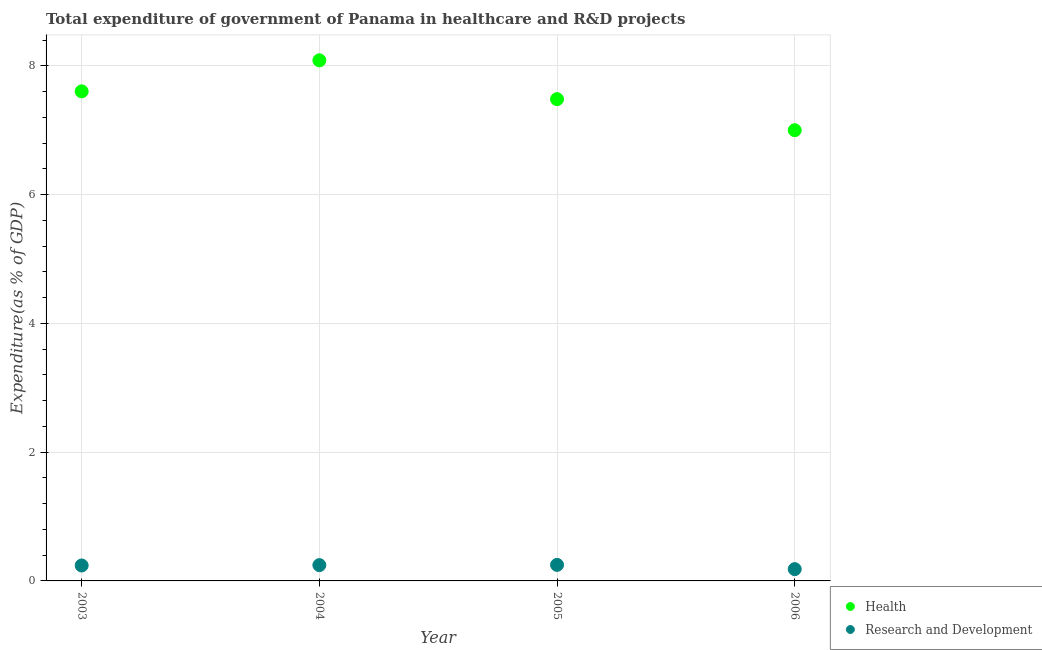How many different coloured dotlines are there?
Provide a short and direct response. 2. Is the number of dotlines equal to the number of legend labels?
Make the answer very short. Yes. What is the expenditure in r&d in 2006?
Provide a succinct answer. 0.18. Across all years, what is the maximum expenditure in r&d?
Keep it short and to the point. 0.25. Across all years, what is the minimum expenditure in healthcare?
Make the answer very short. 7. In which year was the expenditure in healthcare minimum?
Ensure brevity in your answer.  2006. What is the total expenditure in healthcare in the graph?
Keep it short and to the point. 30.18. What is the difference between the expenditure in r&d in 2005 and that in 2006?
Offer a terse response. 0.07. What is the difference between the expenditure in healthcare in 2004 and the expenditure in r&d in 2005?
Make the answer very short. 7.84. What is the average expenditure in r&d per year?
Keep it short and to the point. 0.23. In the year 2003, what is the difference between the expenditure in healthcare and expenditure in r&d?
Give a very brief answer. 7.36. In how many years, is the expenditure in r&d greater than 1.2000000000000002 %?
Your response must be concise. 0. What is the ratio of the expenditure in healthcare in 2004 to that in 2005?
Ensure brevity in your answer.  1.08. Is the expenditure in r&d in 2005 less than that in 2006?
Provide a succinct answer. No. Is the difference between the expenditure in r&d in 2005 and 2006 greater than the difference between the expenditure in healthcare in 2005 and 2006?
Make the answer very short. No. What is the difference between the highest and the second highest expenditure in healthcare?
Your response must be concise. 0.48. What is the difference between the highest and the lowest expenditure in r&d?
Make the answer very short. 0.07. Is the sum of the expenditure in r&d in 2005 and 2006 greater than the maximum expenditure in healthcare across all years?
Your response must be concise. No. Does the expenditure in healthcare monotonically increase over the years?
Ensure brevity in your answer.  No. Is the expenditure in r&d strictly greater than the expenditure in healthcare over the years?
Give a very brief answer. No. Is the expenditure in r&d strictly less than the expenditure in healthcare over the years?
Offer a very short reply. Yes. How many dotlines are there?
Ensure brevity in your answer.  2. What is the difference between two consecutive major ticks on the Y-axis?
Offer a very short reply. 2. Are the values on the major ticks of Y-axis written in scientific E-notation?
Ensure brevity in your answer.  No. Does the graph contain any zero values?
Give a very brief answer. No. Does the graph contain grids?
Provide a short and direct response. Yes. Where does the legend appear in the graph?
Provide a succinct answer. Bottom right. How are the legend labels stacked?
Offer a very short reply. Vertical. What is the title of the graph?
Keep it short and to the point. Total expenditure of government of Panama in healthcare and R&D projects. Does "Export" appear as one of the legend labels in the graph?
Your answer should be very brief. No. What is the label or title of the X-axis?
Your answer should be compact. Year. What is the label or title of the Y-axis?
Offer a terse response. Expenditure(as % of GDP). What is the Expenditure(as % of GDP) in Health in 2003?
Your response must be concise. 7.6. What is the Expenditure(as % of GDP) in Research and Development in 2003?
Give a very brief answer. 0.24. What is the Expenditure(as % of GDP) in Health in 2004?
Provide a short and direct response. 8.09. What is the Expenditure(as % of GDP) of Research and Development in 2004?
Provide a short and direct response. 0.25. What is the Expenditure(as % of GDP) in Health in 2005?
Ensure brevity in your answer.  7.48. What is the Expenditure(as % of GDP) of Research and Development in 2005?
Give a very brief answer. 0.25. What is the Expenditure(as % of GDP) in Health in 2006?
Provide a succinct answer. 7. What is the Expenditure(as % of GDP) of Research and Development in 2006?
Provide a short and direct response. 0.18. Across all years, what is the maximum Expenditure(as % of GDP) in Health?
Give a very brief answer. 8.09. Across all years, what is the maximum Expenditure(as % of GDP) of Research and Development?
Offer a terse response. 0.25. Across all years, what is the minimum Expenditure(as % of GDP) of Health?
Offer a very short reply. 7. Across all years, what is the minimum Expenditure(as % of GDP) in Research and Development?
Give a very brief answer. 0.18. What is the total Expenditure(as % of GDP) of Health in the graph?
Provide a succinct answer. 30.18. What is the total Expenditure(as % of GDP) of Research and Development in the graph?
Provide a short and direct response. 0.92. What is the difference between the Expenditure(as % of GDP) of Health in 2003 and that in 2004?
Provide a short and direct response. -0.48. What is the difference between the Expenditure(as % of GDP) in Research and Development in 2003 and that in 2004?
Your answer should be very brief. -0.01. What is the difference between the Expenditure(as % of GDP) in Health in 2003 and that in 2005?
Keep it short and to the point. 0.12. What is the difference between the Expenditure(as % of GDP) in Research and Development in 2003 and that in 2005?
Give a very brief answer. -0.01. What is the difference between the Expenditure(as % of GDP) of Health in 2003 and that in 2006?
Your answer should be very brief. 0.6. What is the difference between the Expenditure(as % of GDP) in Research and Development in 2003 and that in 2006?
Make the answer very short. 0.06. What is the difference between the Expenditure(as % of GDP) in Health in 2004 and that in 2005?
Offer a very short reply. 0.6. What is the difference between the Expenditure(as % of GDP) of Research and Development in 2004 and that in 2005?
Make the answer very short. -0. What is the difference between the Expenditure(as % of GDP) in Health in 2004 and that in 2006?
Your answer should be compact. 1.09. What is the difference between the Expenditure(as % of GDP) in Research and Development in 2004 and that in 2006?
Offer a very short reply. 0.06. What is the difference between the Expenditure(as % of GDP) in Health in 2005 and that in 2006?
Offer a very short reply. 0.48. What is the difference between the Expenditure(as % of GDP) of Research and Development in 2005 and that in 2006?
Make the answer very short. 0.07. What is the difference between the Expenditure(as % of GDP) of Health in 2003 and the Expenditure(as % of GDP) of Research and Development in 2004?
Provide a succinct answer. 7.36. What is the difference between the Expenditure(as % of GDP) in Health in 2003 and the Expenditure(as % of GDP) in Research and Development in 2005?
Make the answer very short. 7.36. What is the difference between the Expenditure(as % of GDP) in Health in 2003 and the Expenditure(as % of GDP) in Research and Development in 2006?
Your answer should be compact. 7.42. What is the difference between the Expenditure(as % of GDP) in Health in 2004 and the Expenditure(as % of GDP) in Research and Development in 2005?
Give a very brief answer. 7.84. What is the difference between the Expenditure(as % of GDP) in Health in 2004 and the Expenditure(as % of GDP) in Research and Development in 2006?
Give a very brief answer. 7.9. What is the difference between the Expenditure(as % of GDP) in Health in 2005 and the Expenditure(as % of GDP) in Research and Development in 2006?
Your answer should be compact. 7.3. What is the average Expenditure(as % of GDP) of Health per year?
Provide a succinct answer. 7.54. What is the average Expenditure(as % of GDP) in Research and Development per year?
Offer a very short reply. 0.23. In the year 2003, what is the difference between the Expenditure(as % of GDP) of Health and Expenditure(as % of GDP) of Research and Development?
Your answer should be compact. 7.36. In the year 2004, what is the difference between the Expenditure(as % of GDP) of Health and Expenditure(as % of GDP) of Research and Development?
Your answer should be very brief. 7.84. In the year 2005, what is the difference between the Expenditure(as % of GDP) in Health and Expenditure(as % of GDP) in Research and Development?
Give a very brief answer. 7.23. In the year 2006, what is the difference between the Expenditure(as % of GDP) of Health and Expenditure(as % of GDP) of Research and Development?
Your response must be concise. 6.82. What is the ratio of the Expenditure(as % of GDP) of Health in 2003 to that in 2004?
Keep it short and to the point. 0.94. What is the ratio of the Expenditure(as % of GDP) of Research and Development in 2003 to that in 2004?
Give a very brief answer. 0.98. What is the ratio of the Expenditure(as % of GDP) of Health in 2003 to that in 2005?
Provide a succinct answer. 1.02. What is the ratio of the Expenditure(as % of GDP) of Research and Development in 2003 to that in 2005?
Your answer should be very brief. 0.96. What is the ratio of the Expenditure(as % of GDP) of Health in 2003 to that in 2006?
Provide a succinct answer. 1.09. What is the ratio of the Expenditure(as % of GDP) of Research and Development in 2003 to that in 2006?
Keep it short and to the point. 1.31. What is the ratio of the Expenditure(as % of GDP) in Health in 2004 to that in 2005?
Provide a short and direct response. 1.08. What is the ratio of the Expenditure(as % of GDP) in Research and Development in 2004 to that in 2005?
Keep it short and to the point. 0.99. What is the ratio of the Expenditure(as % of GDP) in Health in 2004 to that in 2006?
Your answer should be very brief. 1.16. What is the ratio of the Expenditure(as % of GDP) in Research and Development in 2004 to that in 2006?
Provide a short and direct response. 1.34. What is the ratio of the Expenditure(as % of GDP) in Health in 2005 to that in 2006?
Keep it short and to the point. 1.07. What is the ratio of the Expenditure(as % of GDP) in Research and Development in 2005 to that in 2006?
Offer a terse response. 1.36. What is the difference between the highest and the second highest Expenditure(as % of GDP) of Health?
Your response must be concise. 0.48. What is the difference between the highest and the second highest Expenditure(as % of GDP) in Research and Development?
Make the answer very short. 0. What is the difference between the highest and the lowest Expenditure(as % of GDP) in Health?
Offer a terse response. 1.09. What is the difference between the highest and the lowest Expenditure(as % of GDP) of Research and Development?
Your response must be concise. 0.07. 